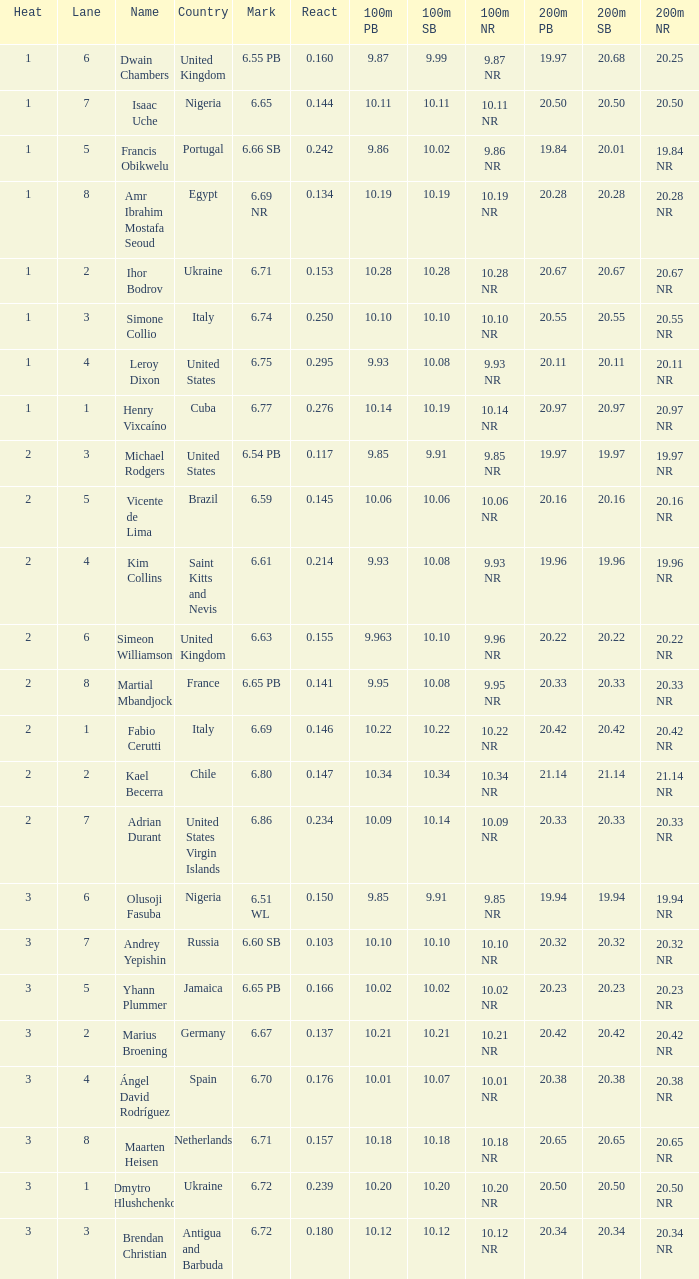What is the lowest Lane, when Country is France, and when React is less than 0.14100000000000001? 8.0. 